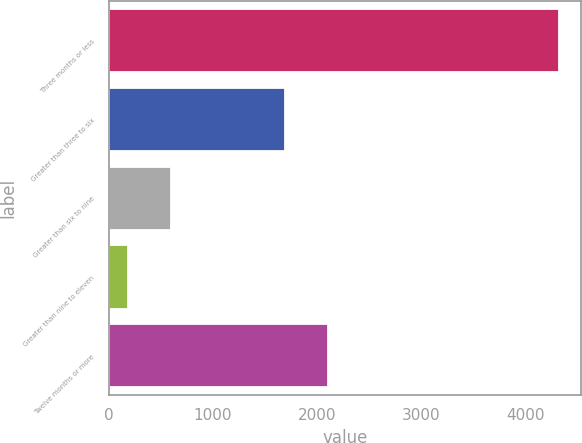<chart> <loc_0><loc_0><loc_500><loc_500><bar_chart><fcel>Three months or less<fcel>Greater than three to six<fcel>Greater than six to nine<fcel>Greater than nine to eleven<fcel>Twelve months or more<nl><fcel>4315<fcel>1694<fcel>601<fcel>188<fcel>2106.7<nl></chart> 